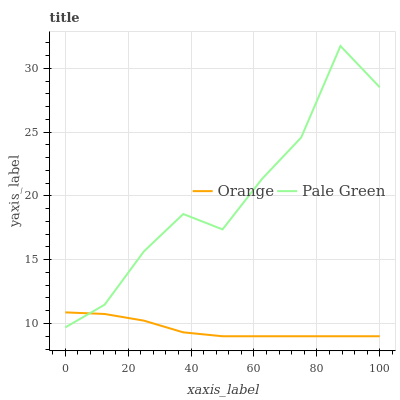Does Orange have the minimum area under the curve?
Answer yes or no. Yes. Does Pale Green have the maximum area under the curve?
Answer yes or no. Yes. Does Pale Green have the minimum area under the curve?
Answer yes or no. No. Is Orange the smoothest?
Answer yes or no. Yes. Is Pale Green the roughest?
Answer yes or no. Yes. Is Pale Green the smoothest?
Answer yes or no. No. Does Orange have the lowest value?
Answer yes or no. Yes. Does Pale Green have the lowest value?
Answer yes or no. No. Does Pale Green have the highest value?
Answer yes or no. Yes. Does Orange intersect Pale Green?
Answer yes or no. Yes. Is Orange less than Pale Green?
Answer yes or no. No. Is Orange greater than Pale Green?
Answer yes or no. No. 